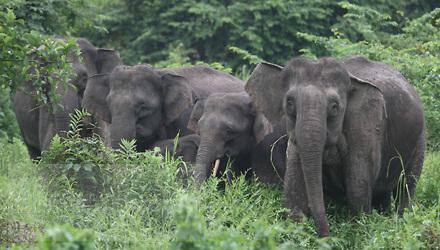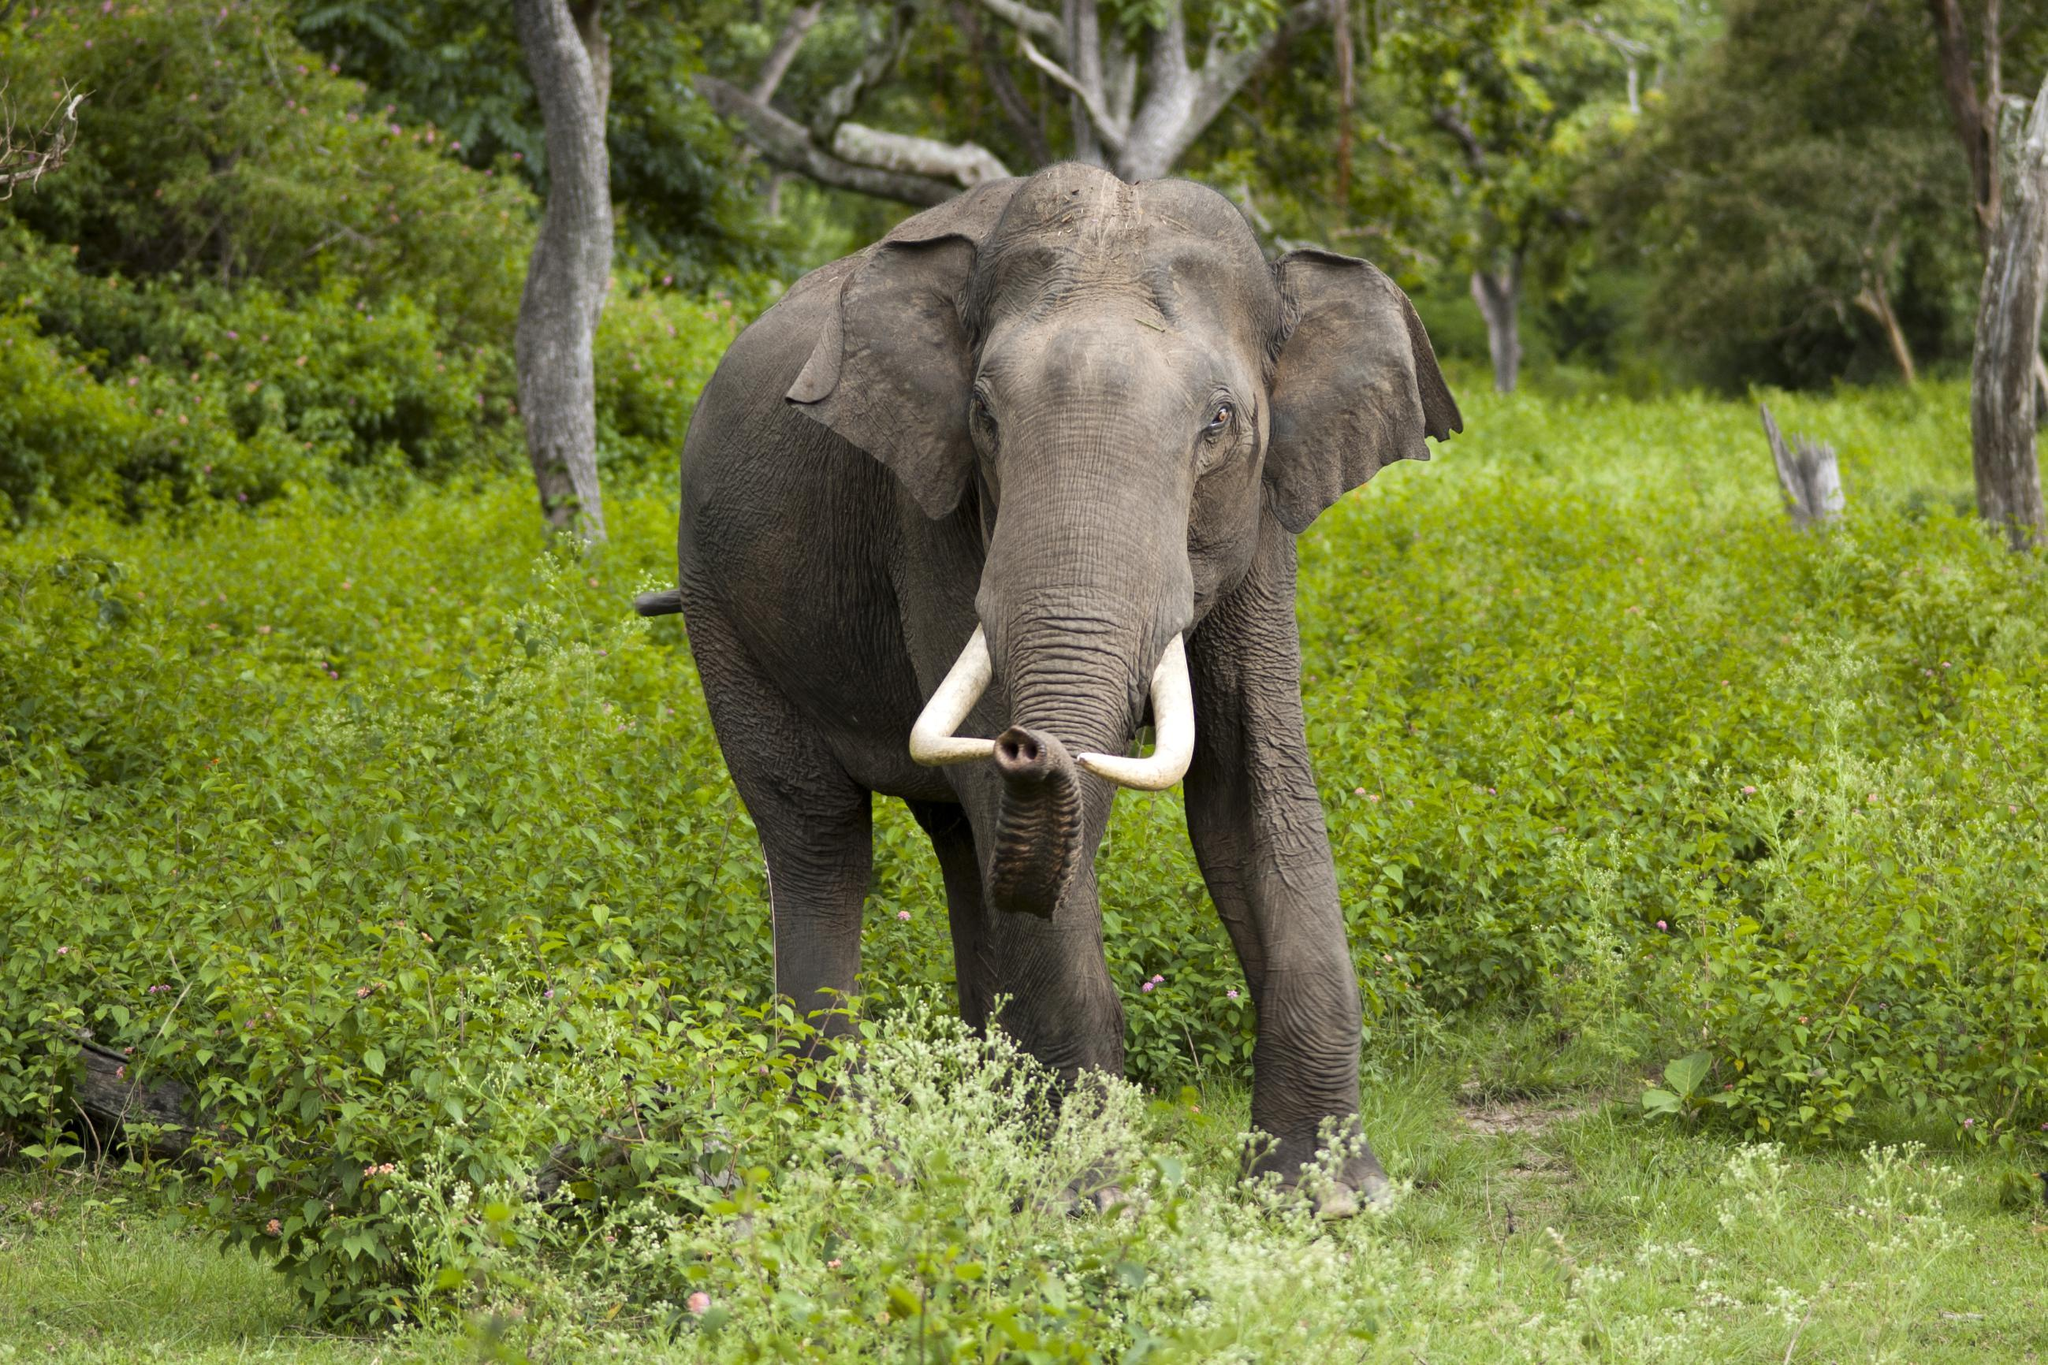The first image is the image on the left, the second image is the image on the right. Analyze the images presented: Is the assertion "The right image contains only one elephant." valid? Answer yes or no. Yes. The first image is the image on the left, the second image is the image on the right. Analyze the images presented: Is the assertion "The right image contains a single elephant with large tusks." valid? Answer yes or no. Yes. 